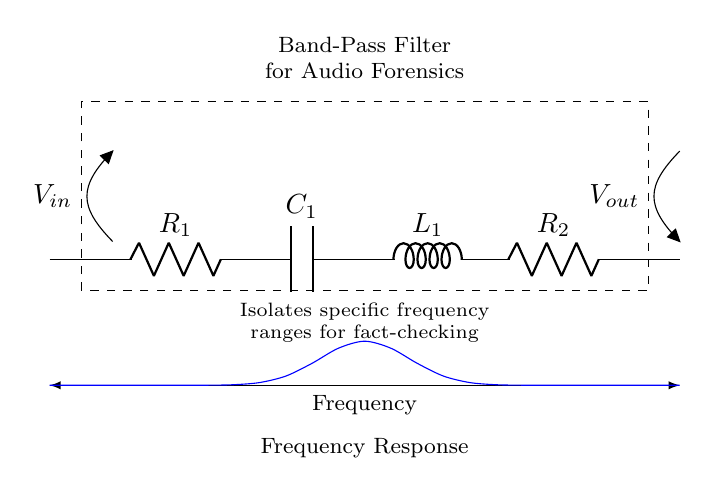What is the input voltage in this circuit? The input voltage, labeled as V_{in}, is located at the point where the voltage is applied to the circuit, which is between the first short and the resistor R_1.
Answer: V_{in} What components are present in this band-pass filter? The circuit features two resistors (R_1 and R_2), one capacitor (C_1), and one inductor (L_1). These components work together to form the band-pass characteristics of the filter.
Answer: R_1, R_2, C_1, L_1 How many reactive components are included in the filter? In this circuit, there are two reactive components: one capacitor (C_1) and one inductor (L_1). These components are responsible for the filtering action of the circuit.
Answer: 2 What is the purpose of this circuit? The primary purpose of the circuit is to isolate specific frequency ranges in audio forensics, which is crucial for accurate fact-checking of audio content.
Answer: Isolates specific frequency ranges What does the dashed rectangle represent? The dashed rectangle encloses the entire band-pass filter components, indicating that they collectively operate as a single unit within the circuit for audio processing.
Answer: Circuit boundary What occurs at the output of this filter? At the output, labeled as V_{out}, the filtered audio signal is obtained, which contains only the desired frequency components while attenuating others outside the set range.
Answer: Filtered audio signal What can you infer from the frequency response curve? The frequency response curve depicted shows that the filter allows a certain range of frequencies to pass through while attenuating frequencies outside this range, indicating its effectiveness in audio forensic applications.
Answer: Band-pass characteristic 